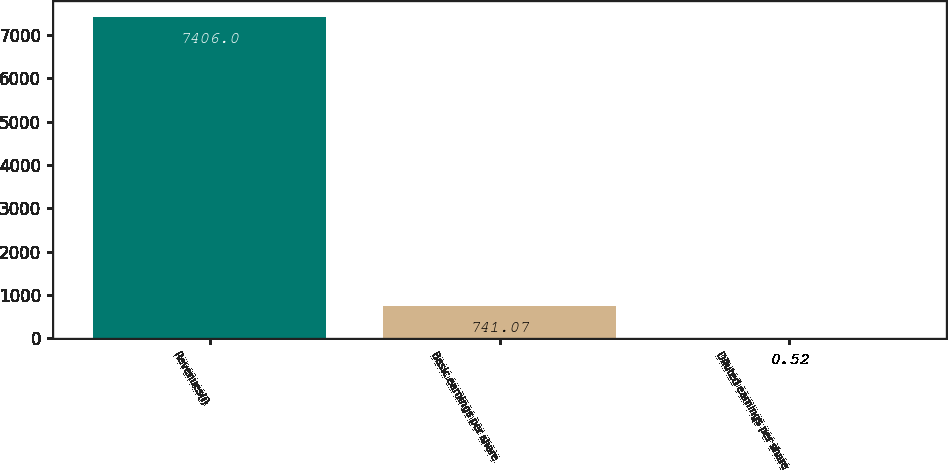Convert chart. <chart><loc_0><loc_0><loc_500><loc_500><bar_chart><fcel>Revenues(i)<fcel>Basic earnings per share<fcel>Diluted earnings per share<nl><fcel>7406<fcel>741.07<fcel>0.52<nl></chart> 